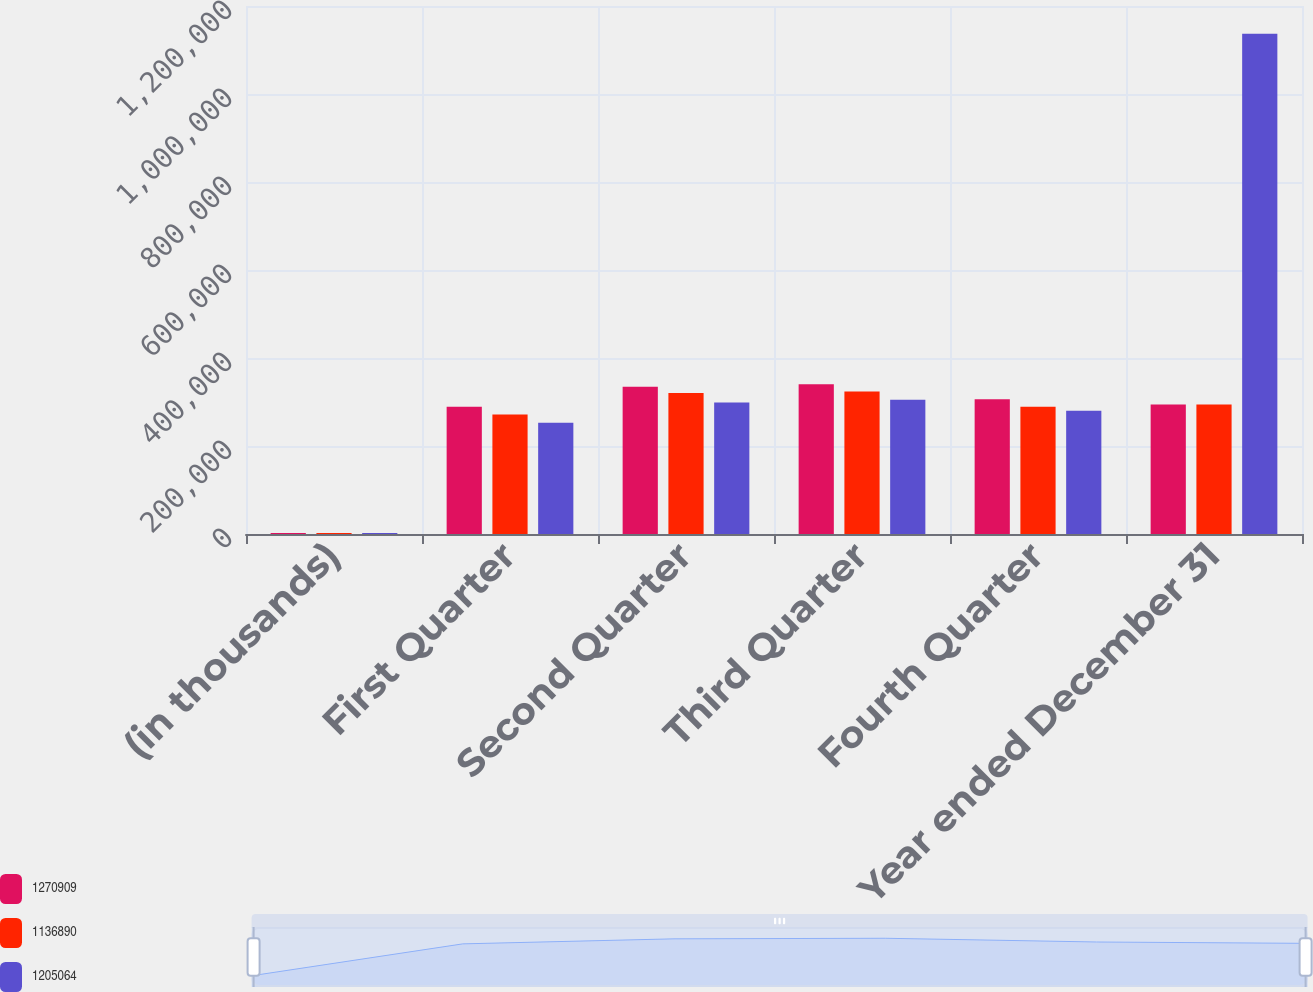Convert chart to OTSL. <chart><loc_0><loc_0><loc_500><loc_500><stacked_bar_chart><ecel><fcel>(in thousands)<fcel>First Quarter<fcel>Second Quarter<fcel>Third Quarter<fcel>Fourth Quarter<fcel>Year ended December 31<nl><fcel>1.27091e+06<fcel>2012<fcel>289465<fcel>334872<fcel>340179<fcel>306393<fcel>294134<nl><fcel>1.13689e+06<fcel>2011<fcel>271643<fcel>320436<fcel>323929<fcel>289056<fcel>294134<nl><fcel>1.20506e+06<fcel>2010<fcel>253041<fcel>298803<fcel>305118<fcel>279928<fcel>1.13689e+06<nl></chart> 